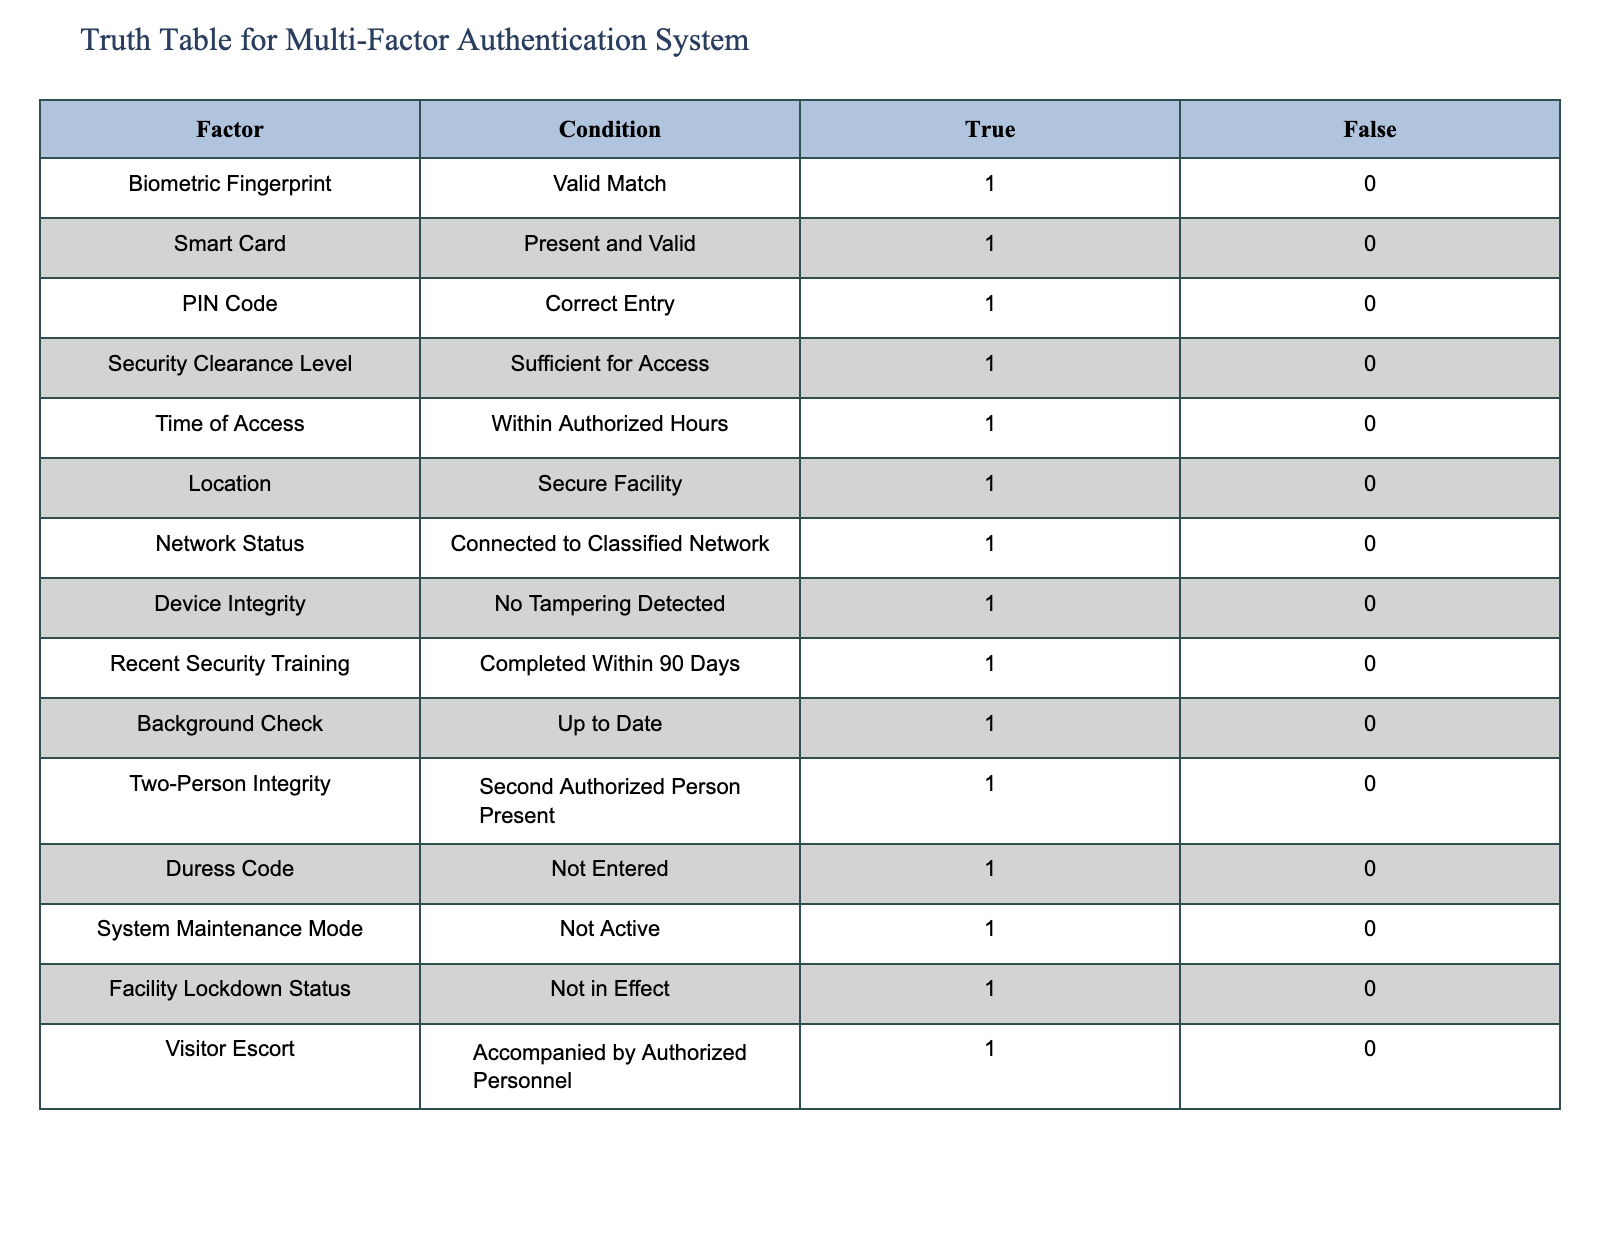What is the condition for the Biometric Fingerprint factor to be considered valid? The table indicates that the condition for the Biometric Fingerprint factor to be considered valid is a "Valid Match," which corresponds to a value of 1 for true.
Answer: Valid Match How many factors have a true condition of 1? By analyzing the table, it shows that all 15 factors have a true value of 1, meaning they all require a condition to be fulfilled to confirm multi-factor authentication.
Answer: 15 Is the Security Clearance Level required for access sufficient? According to the table, the answer is true since the condition "Sufficient for Access" has a corresponding true value of 1.
Answer: Yes Which condition is required for the Visitor Escort factor? The condition required for the Visitor Escort factor is "Accompanied by Authorized Personnel," which has a true value of 1.
Answer: Accompanied by Authorized Personnel If only the Security Clearance Level and Time of Access are true, can access still be granted? No, access cannot be granted based solely on these two factors because the majority of the other factors have a required condition, and unless they are all met, access will be denied.
Answer: No What is the only condition that must not be entered for Duress Code? The table specifies that the condition for the Duress Code factor must be "Not Entered," which corresponds to a true value being 1.
Answer: Not Entered How many conditions are centered around security personnel or escorts? There are two conditions in the table that center around security personnel or escorts: "Two-Person Integrity" and "Visitor Escort." Both of them emphasize the presence of authorized personnel.
Answer: 2 If only the Biometric Fingerprint and PIN Code conditions are satisfied, what is the status of authentication? The status of authentication would be denied because there are several other required conditions that must also be true for full access verification.
Answer: Denied What factors must be examined to ensure secure network access? The factors to be examined for secure network access include "Network Status" which needs to be "Connected to Classified Network," and "Device Integrity" which must be "No Tampering Detected." Both must be fulfilled for secure access.
Answer: Network Status, Device Integrity 